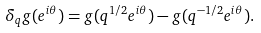Convert formula to latex. <formula><loc_0><loc_0><loc_500><loc_500>\delta _ { q } g ( e ^ { i \theta } ) = g ( q ^ { 1 / 2 } e ^ { i \theta } ) - g ( q ^ { - 1 / 2 } e ^ { i \theta } ) .</formula> 